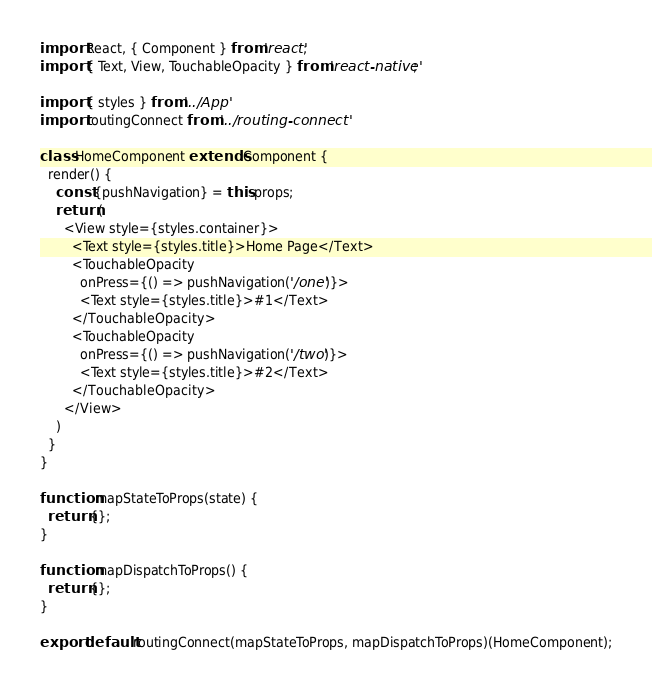<code> <loc_0><loc_0><loc_500><loc_500><_JavaScript_>import React, { Component } from 'react';
import { Text, View, TouchableOpacity } from 'react-native';

import { styles } from '../App'
import routingConnect from '../routing-connect'

class HomeComponent extends Component {
  render() {
    const {pushNavigation} = this.props;
    return (
      <View style={styles.container}>
        <Text style={styles.title}>Home Page</Text>
        <TouchableOpacity
          onPress={() => pushNavigation('/one')}>
          <Text style={styles.title}>#1</Text>
        </TouchableOpacity>
        <TouchableOpacity
          onPress={() => pushNavigation('/two')}>
          <Text style={styles.title}>#2</Text>
        </TouchableOpacity>
      </View>
    )
  }
}

function mapStateToProps(state) {
  return {};
}

function mapDispatchToProps() {
  return {};
}

export default routingConnect(mapStateToProps, mapDispatchToProps)(HomeComponent);
</code> 